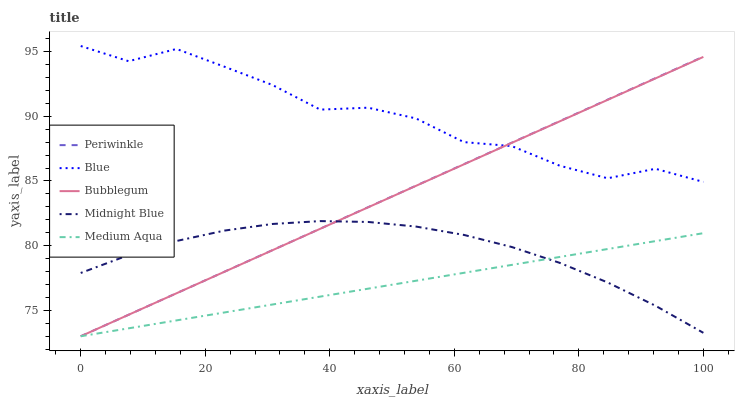Does Medium Aqua have the minimum area under the curve?
Answer yes or no. Yes. Does Blue have the maximum area under the curve?
Answer yes or no. Yes. Does Periwinkle have the minimum area under the curve?
Answer yes or no. No. Does Periwinkle have the maximum area under the curve?
Answer yes or no. No. Is Medium Aqua the smoothest?
Answer yes or no. Yes. Is Blue the roughest?
Answer yes or no. Yes. Is Periwinkle the smoothest?
Answer yes or no. No. Is Periwinkle the roughest?
Answer yes or no. No. Does Midnight Blue have the lowest value?
Answer yes or no. No. Does Periwinkle have the highest value?
Answer yes or no. No. Is Medium Aqua less than Blue?
Answer yes or no. Yes. Is Blue greater than Midnight Blue?
Answer yes or no. Yes. Does Medium Aqua intersect Blue?
Answer yes or no. No. 